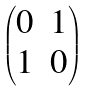<formula> <loc_0><loc_0><loc_500><loc_500>\begin{pmatrix} { 0 } & { 1 } \\ { 1 } & { 0 } \end{pmatrix}</formula> 